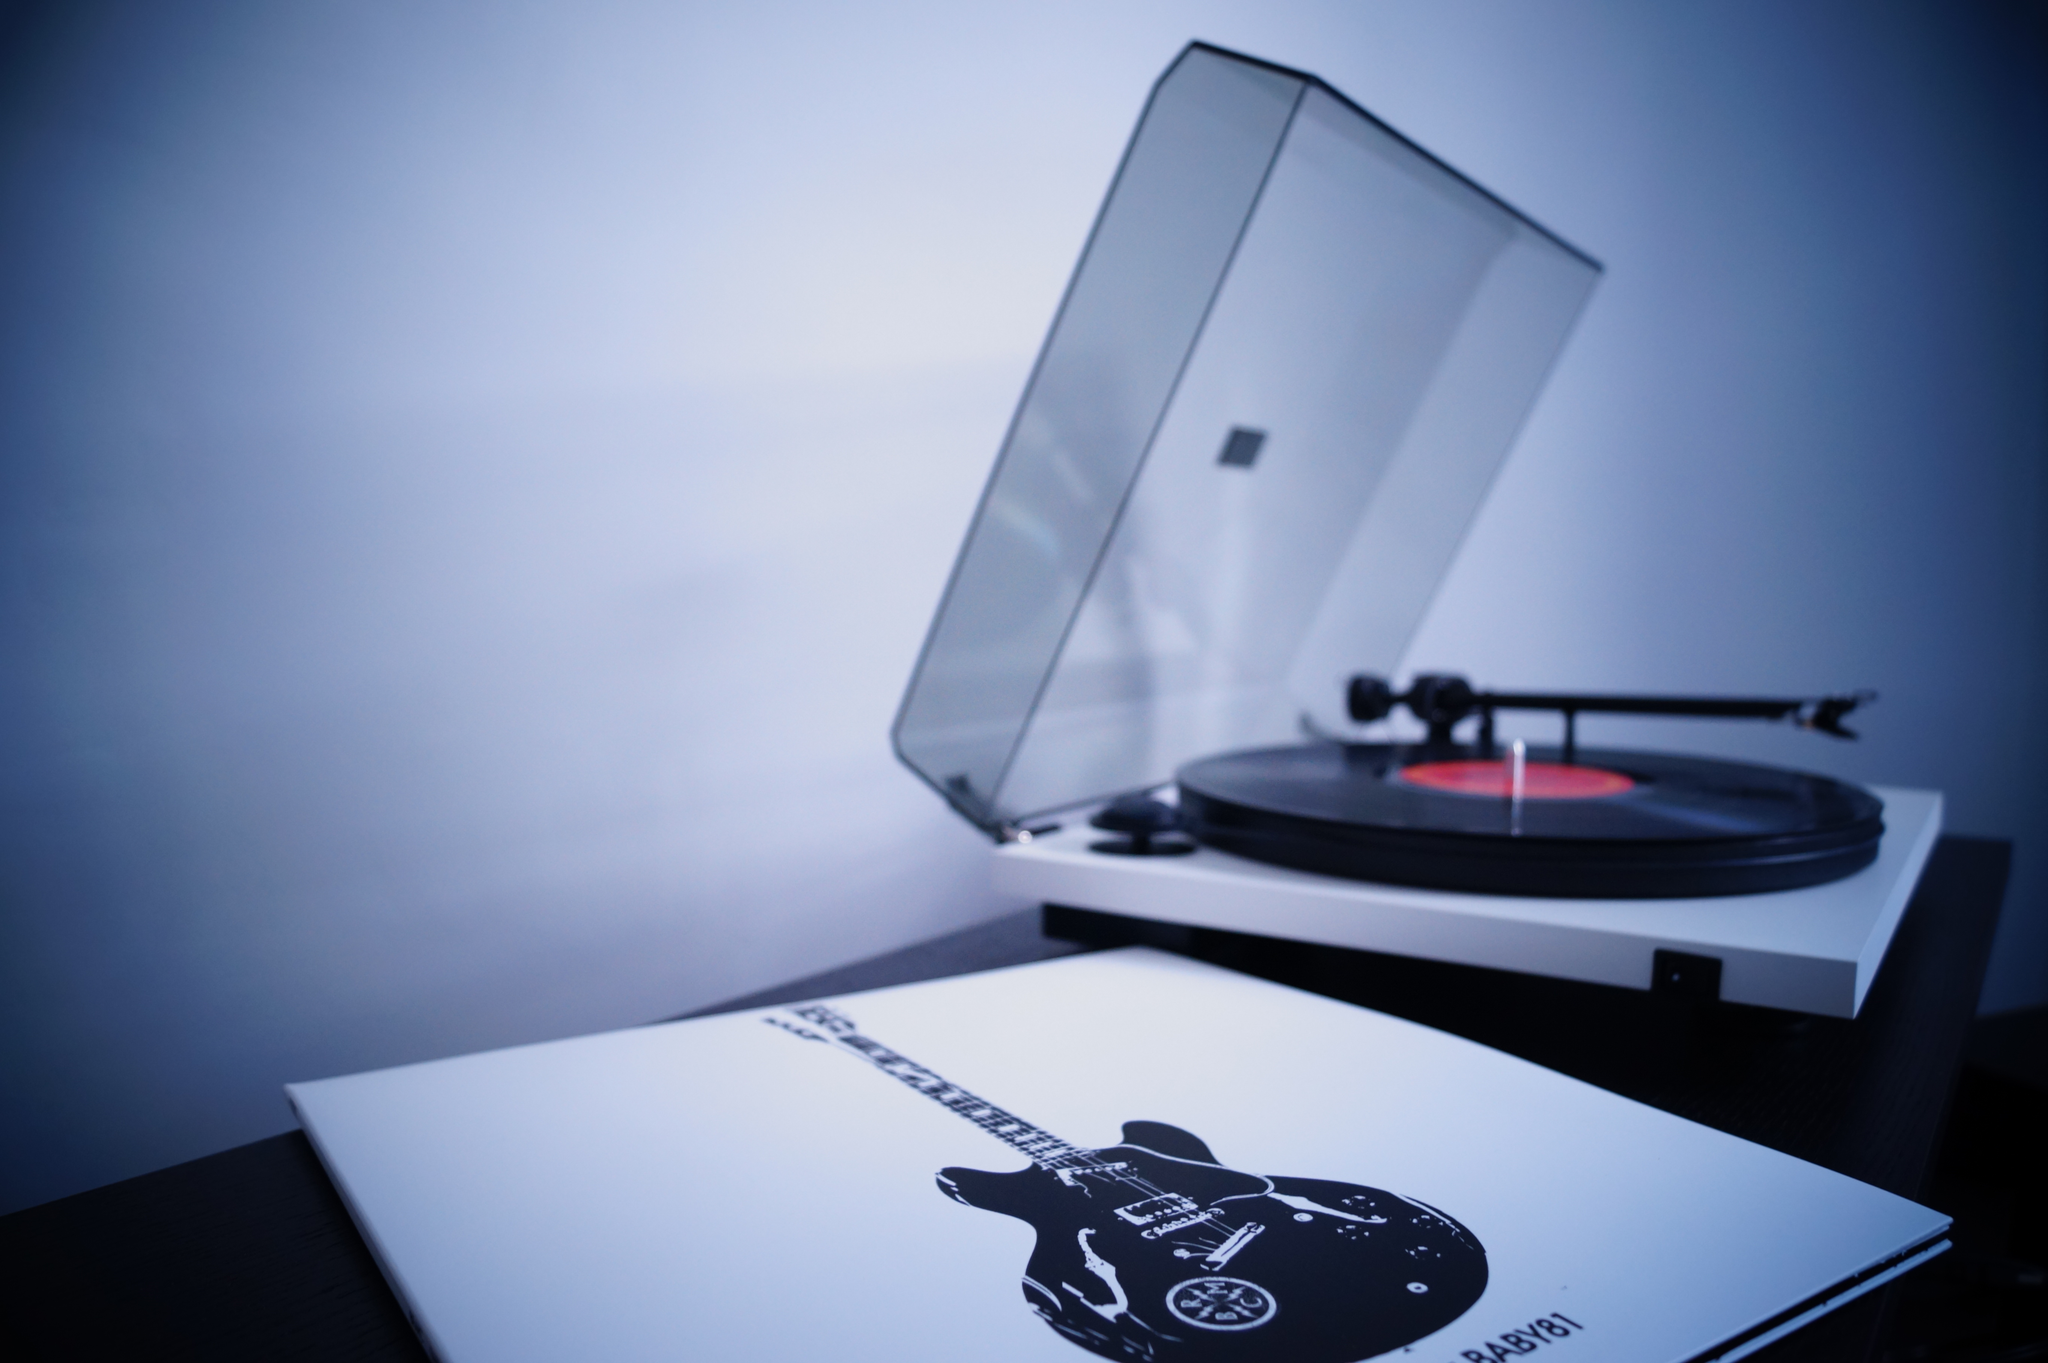Please provide a concise description of this image. In this image there is a gramophone record player and a book on the table, and in the background there is a wall. 